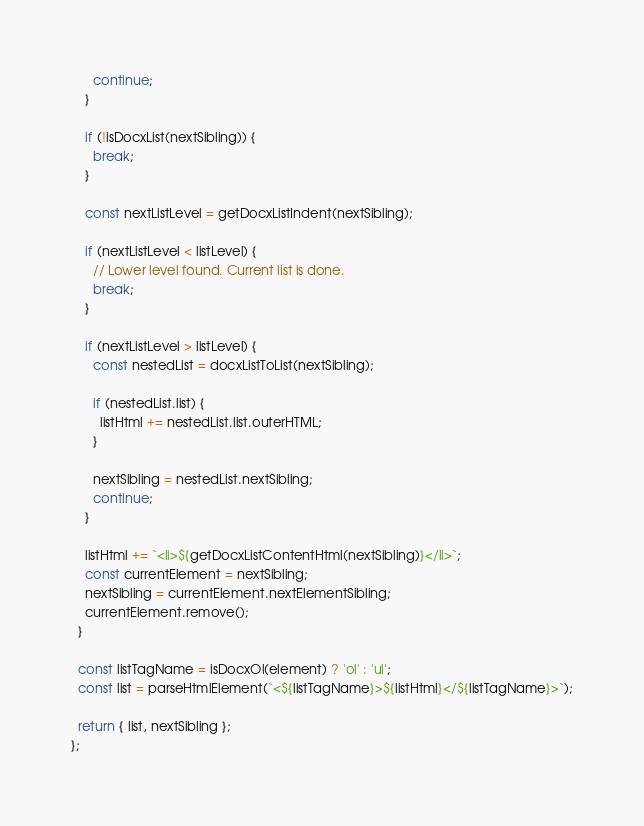Convert code to text. <code><loc_0><loc_0><loc_500><loc_500><_TypeScript_>      continue;
    }

    if (!isDocxList(nextSibling)) {
      break;
    }

    const nextListLevel = getDocxListIndent(nextSibling);

    if (nextListLevel < listLevel) {
      // Lower level found. Current list is done.
      break;
    }

    if (nextListLevel > listLevel) {
      const nestedList = docxListToList(nextSibling);

      if (nestedList.list) {
        listHtml += nestedList.list.outerHTML;
      }

      nextSibling = nestedList.nextSibling;
      continue;
    }

    listHtml += `<li>${getDocxListContentHtml(nextSibling)}</li>`;
    const currentElement = nextSibling;
    nextSibling = currentElement.nextElementSibling;
    currentElement.remove();
  }

  const listTagName = isDocxOl(element) ? 'ol' : 'ul';
  const list = parseHtmlElement(`<${listTagName}>${listHtml}</${listTagName}>`);

  return { list, nextSibling };
};
</code> 